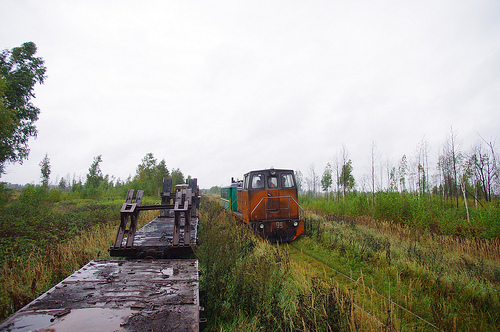Can you speculate on the type of train and its potential use based on the image? The train's design with a flat front, short length, and a single visible carriage suggests it might be a locomotive designed for shunting or moving railcars within a rail yard or industrial complex. Its robust build also suggests it could be suited for transporting goods or materials over short distances, possibly serving an agricultural or manufacturing area. 